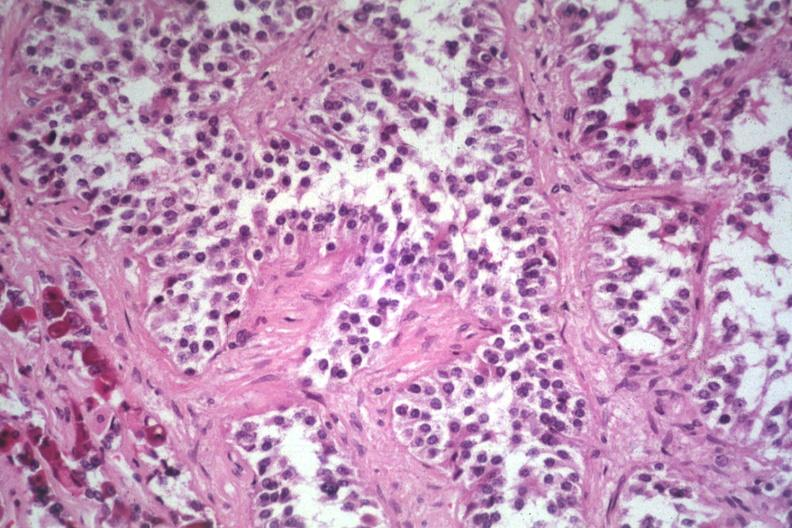what is present?
Answer the question using a single word or phrase. Pituitary 